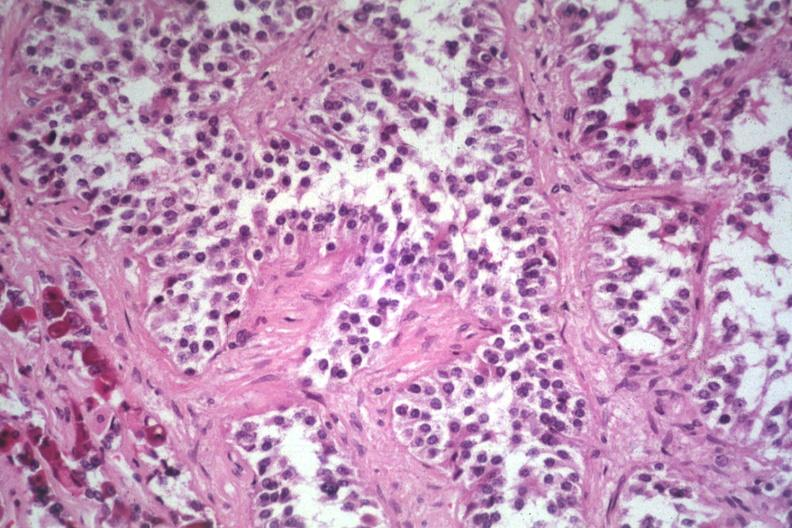what is present?
Answer the question using a single word or phrase. Pituitary 